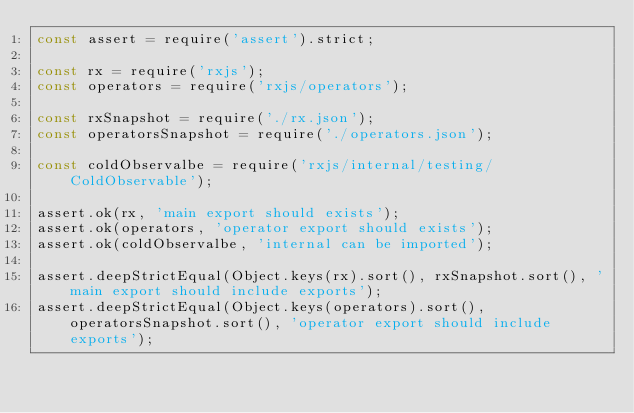Convert code to text. <code><loc_0><loc_0><loc_500><loc_500><_JavaScript_>const assert = require('assert').strict;

const rx = require('rxjs');
const operators = require('rxjs/operators');

const rxSnapshot = require('./rx.json');
const operatorsSnapshot = require('./operators.json');

const coldObservalbe = require('rxjs/internal/testing/ColdObservable');

assert.ok(rx, 'main export should exists');
assert.ok(operators, 'operator export should exists');
assert.ok(coldObservalbe, 'internal can be imported');

assert.deepStrictEqual(Object.keys(rx).sort(), rxSnapshot.sort(), 'main export should include exports');
assert.deepStrictEqual(Object.keys(operators).sort(), operatorsSnapshot.sort(), 'operator export should include exports');
</code> 